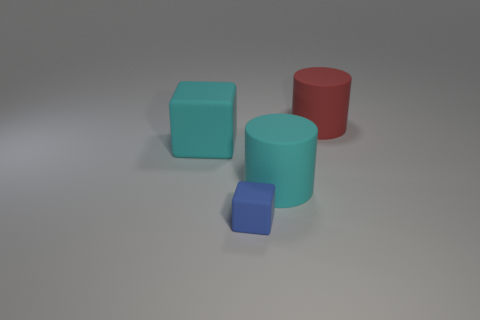Add 1 large red things. How many objects exist? 5 Add 4 small blue objects. How many small blue objects are left? 5 Add 2 red objects. How many red objects exist? 3 Subtract 0 yellow cylinders. How many objects are left? 4 Subtract all red matte cylinders. Subtract all big rubber objects. How many objects are left? 0 